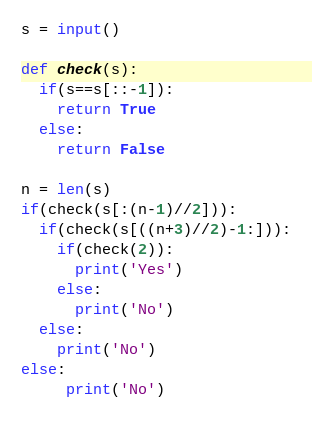<code> <loc_0><loc_0><loc_500><loc_500><_Python_>s = input()

def check(s):
  if(s==s[::-1]):
    return True
  else:
    return False
  
n = len(s)
if(check(s[:(n-1)//2])):
  if(check(s[((n+3)//2)-1:])):
    if(check(2)):
      print('Yes')
    else:
      print('No')
  else:
    print('No')
else:
     print('No')</code> 